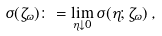Convert formula to latex. <formula><loc_0><loc_0><loc_500><loc_500>\sigma ( { { \zeta } _ { \omega } } ) \colon = \lim _ { \eta \downarrow 0 } \sigma ( \eta ; { { \zeta } _ { \omega } } ) \, ,</formula> 